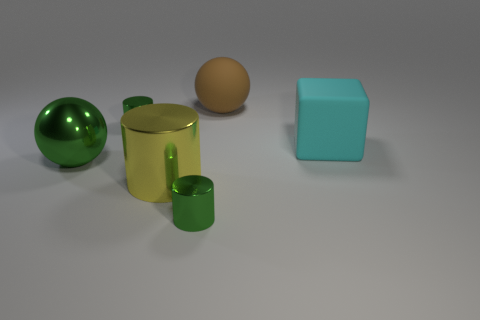Add 2 green cylinders. How many objects exist? 8 Subtract all spheres. How many objects are left? 4 Add 5 yellow metal objects. How many yellow metal objects are left? 6 Add 5 tiny metal objects. How many tiny metal objects exist? 7 Subtract 0 blue cylinders. How many objects are left? 6 Subtract all large brown balls. Subtract all big cyan things. How many objects are left? 4 